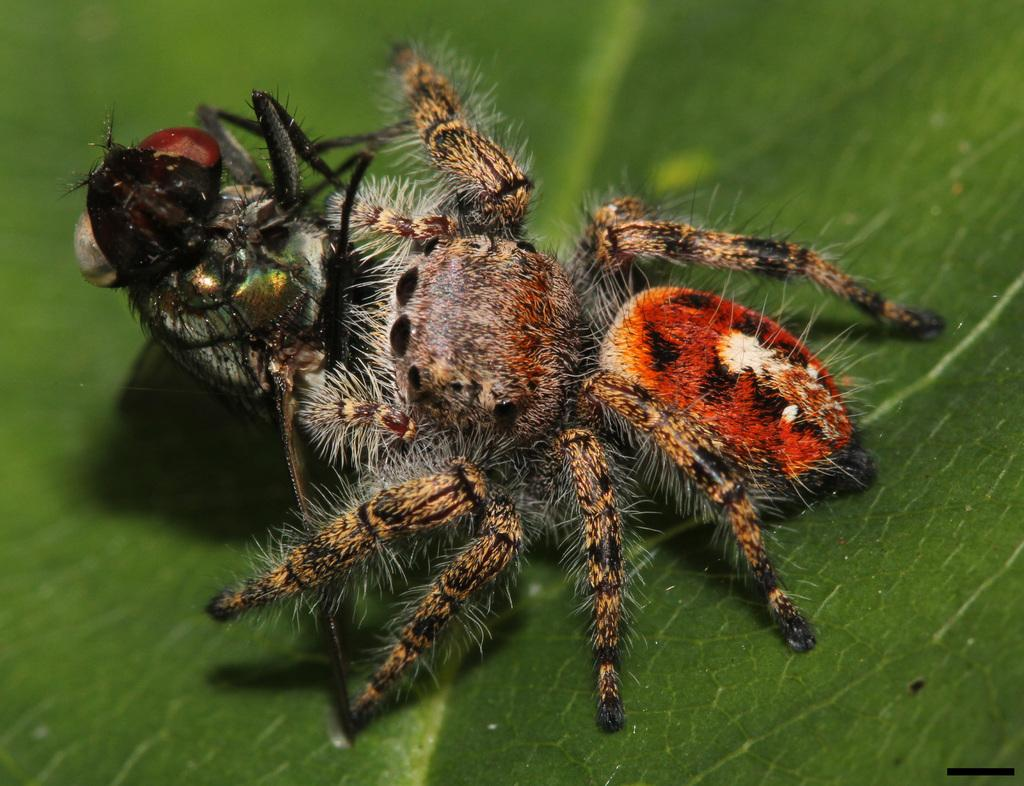What type of creature is present in the image? There is an insect in the image. What is the insect resting on in the image? The insect is on a green surface. How comfortable is the insect feeling in the image? The image does not provide information about the insect's comfort level, so it cannot be determined. 